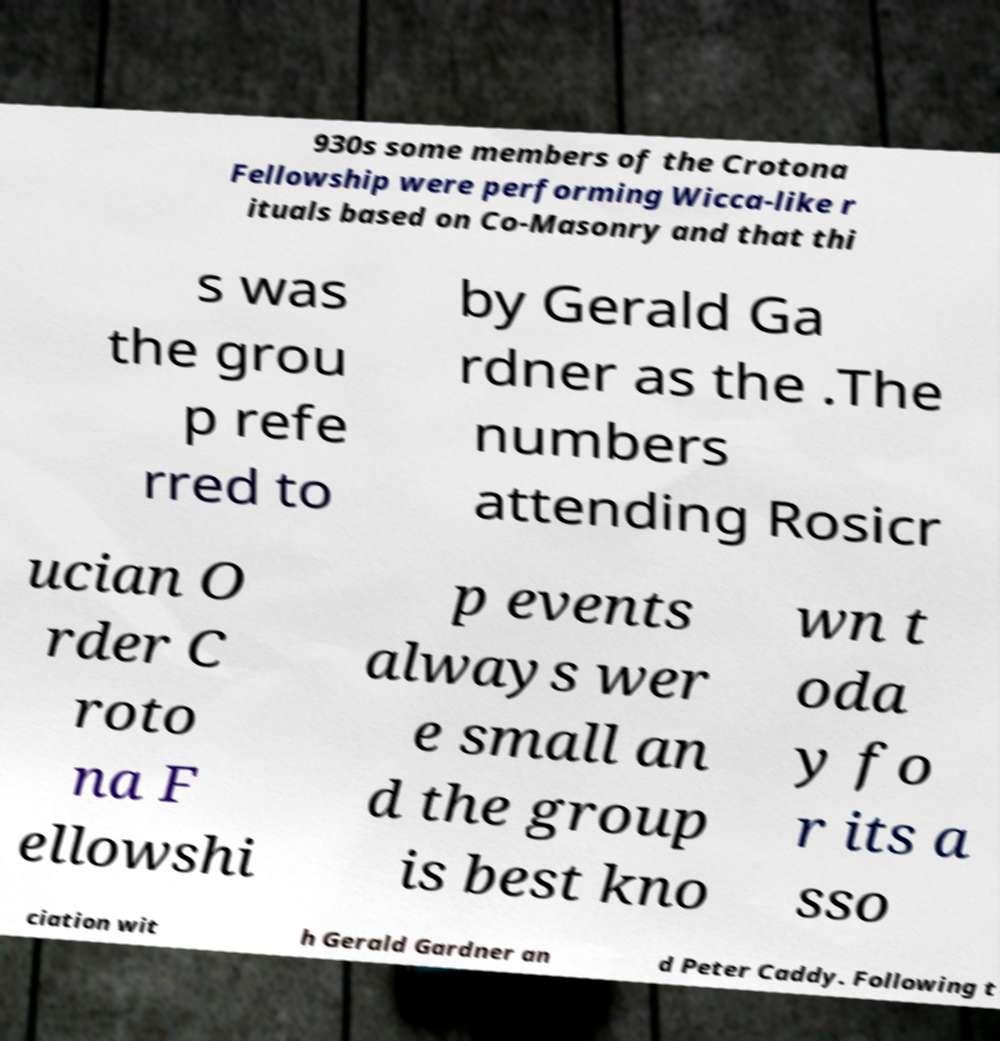What messages or text are displayed in this image? I need them in a readable, typed format. 930s some members of the Crotona Fellowship were performing Wicca-like r ituals based on Co-Masonry and that thi s was the grou p refe rred to by Gerald Ga rdner as the .The numbers attending Rosicr ucian O rder C roto na F ellowshi p events always wer e small an d the group is best kno wn t oda y fo r its a sso ciation wit h Gerald Gardner an d Peter Caddy. Following t 